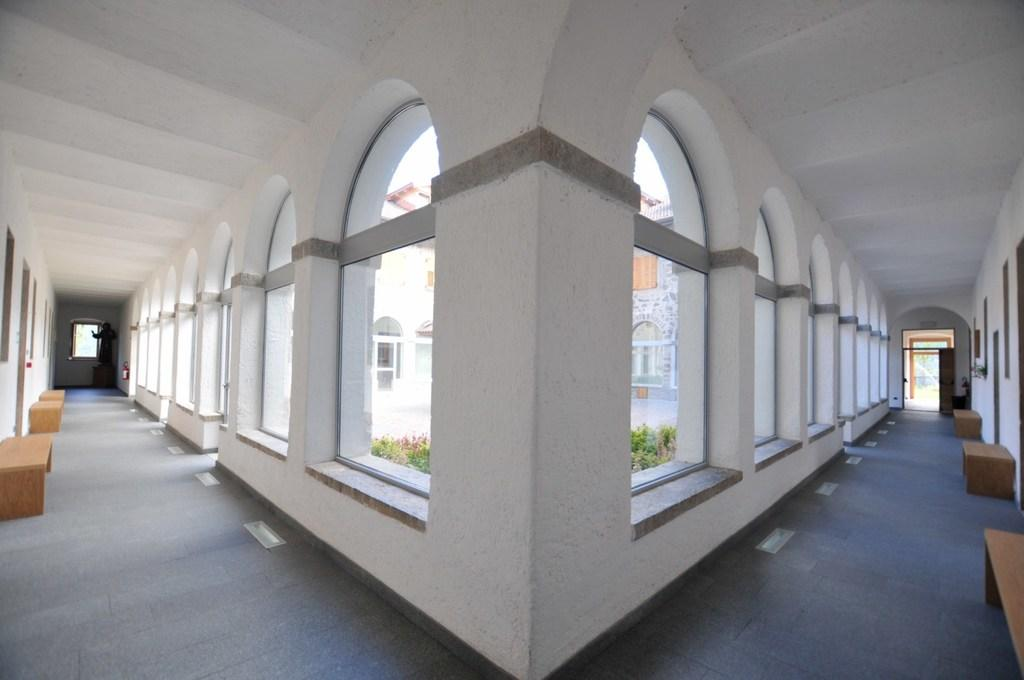What is the main subject of the image? The main subject of the image is a building. Are there any additional features or objects in the image? Yes, there are benches in the image. What can be seen on the building's wall? There are windows in the building's wall. Can you tell me how many bulbs are illuminated in the image? There is no mention of bulbs in the image, so it is not possible to determine how many are illuminated. 